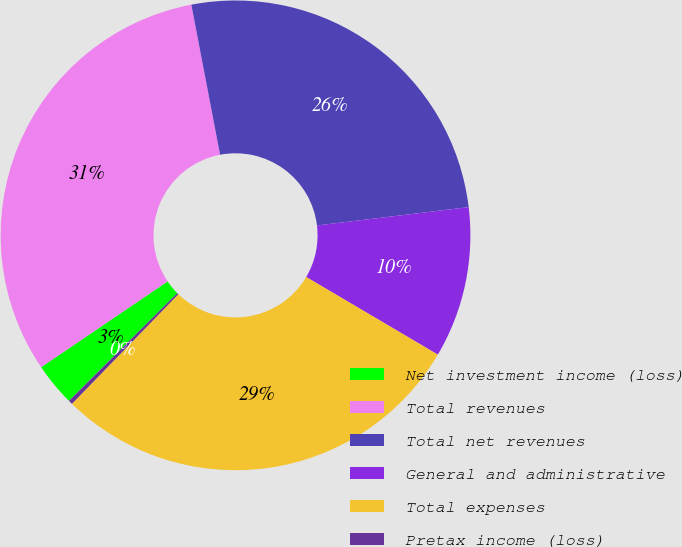Convert chart to OTSL. <chart><loc_0><loc_0><loc_500><loc_500><pie_chart><fcel>Net investment income (loss)<fcel>Total revenues<fcel>Total net revenues<fcel>General and administrative<fcel>Total expenses<fcel>Pretax income (loss)<nl><fcel>2.97%<fcel>31.48%<fcel>26.1%<fcel>10.4%<fcel>28.79%<fcel>0.28%<nl></chart> 